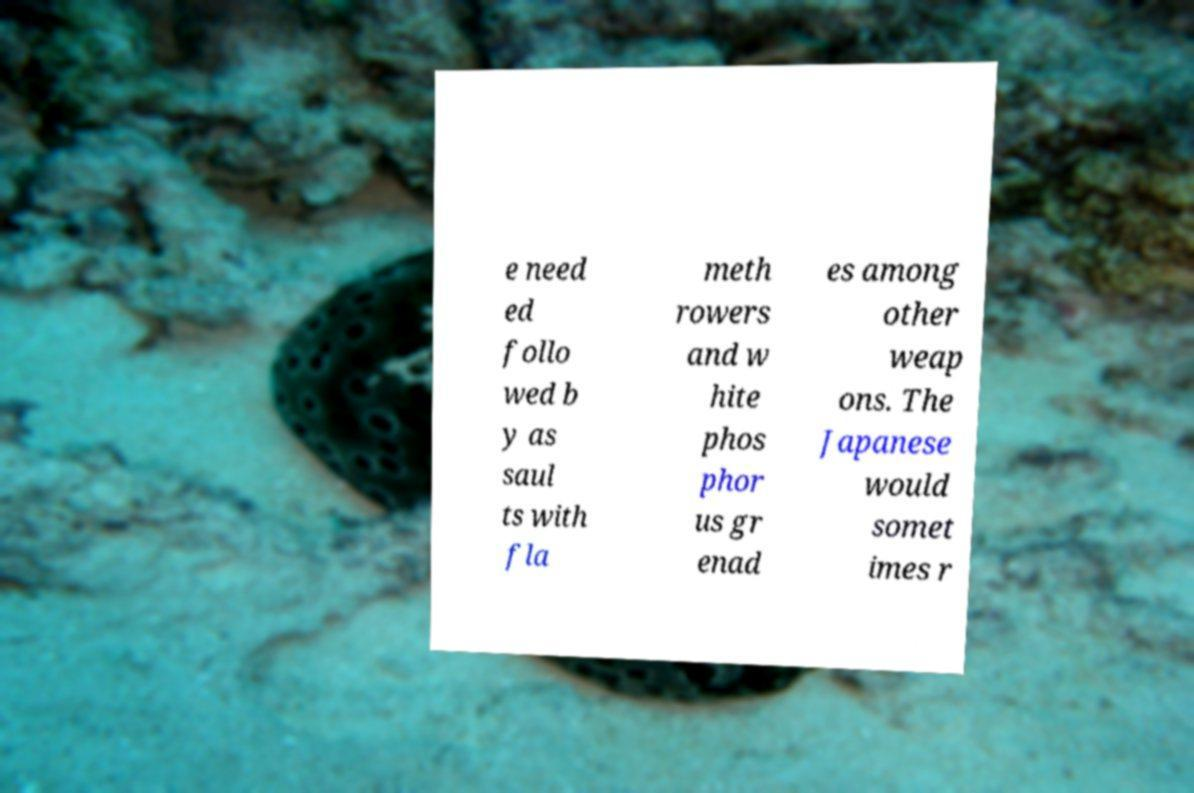Could you assist in decoding the text presented in this image and type it out clearly? e need ed follo wed b y as saul ts with fla meth rowers and w hite phos phor us gr enad es among other weap ons. The Japanese would somet imes r 